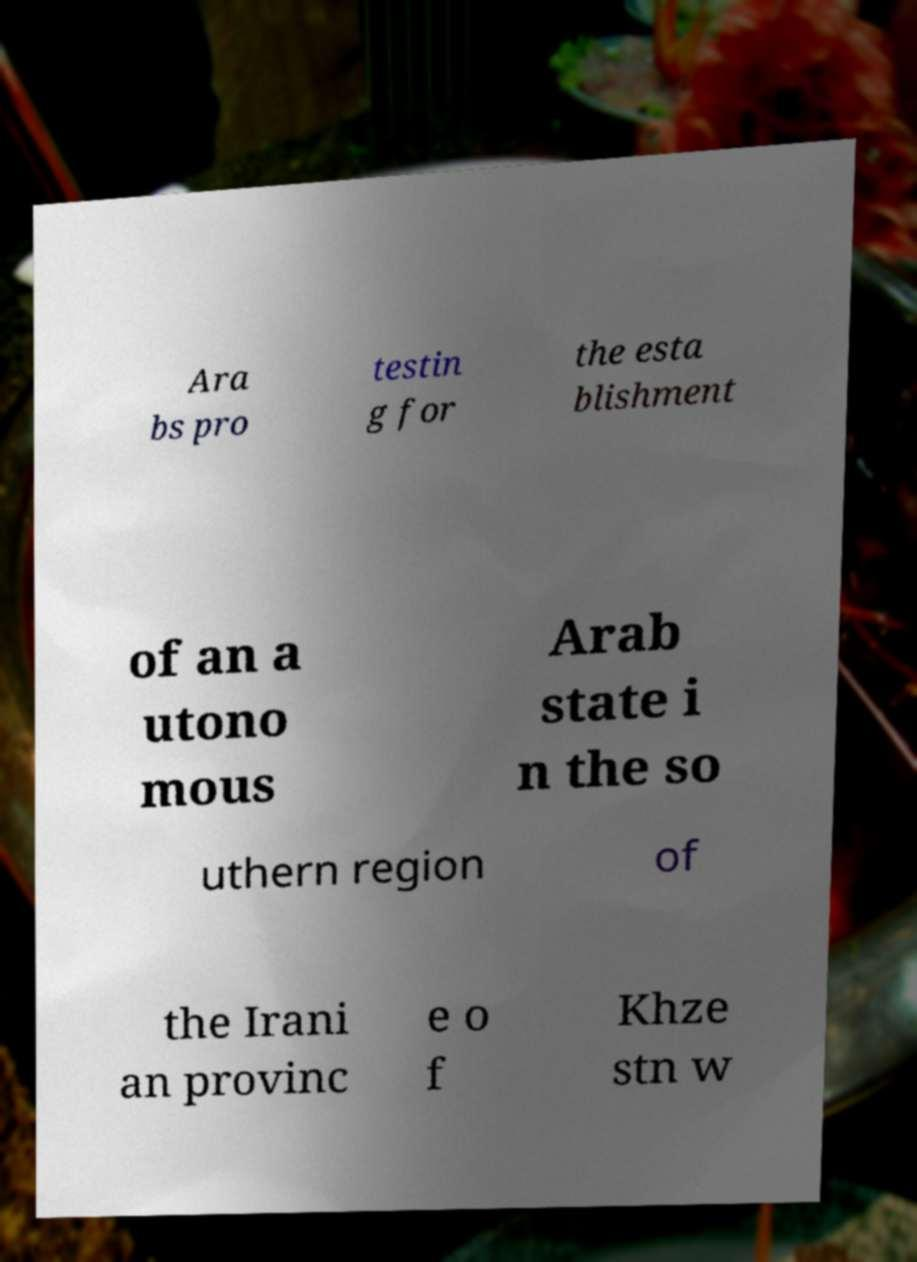Could you extract and type out the text from this image? Ara bs pro testin g for the esta blishment of an a utono mous Arab state i n the so uthern region of the Irani an provinc e o f Khze stn w 